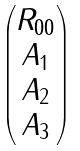<formula> <loc_0><loc_0><loc_500><loc_500>\begin{pmatrix} R _ { 0 0 } \\ A _ { 1 } \\ A _ { 2 } \\ A _ { 3 } \\ \end{pmatrix}</formula> 